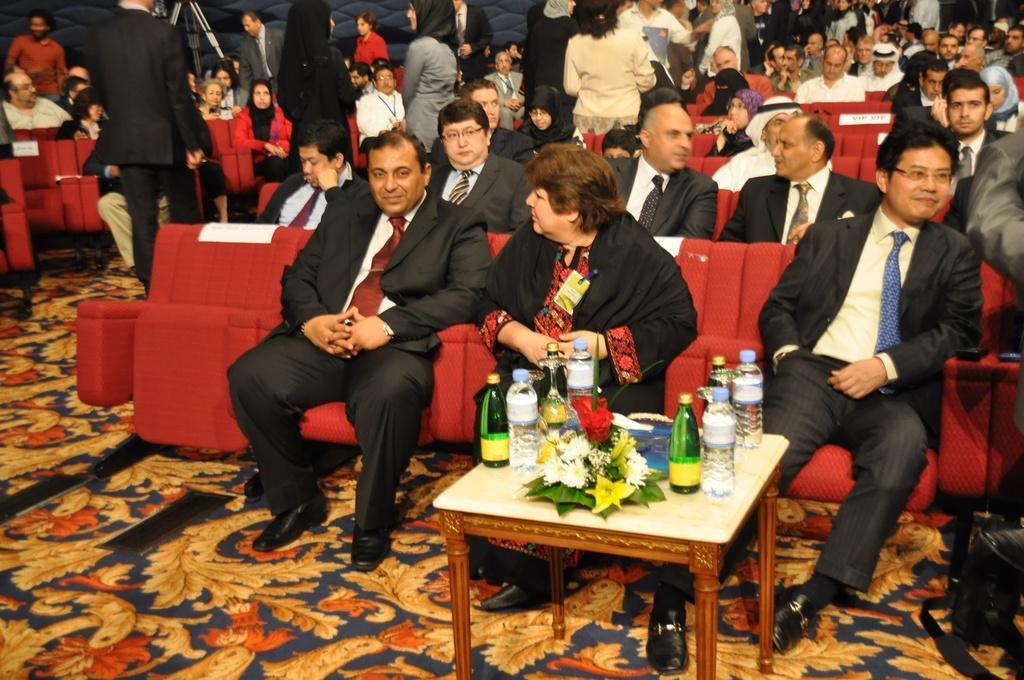How would you summarize this image in a sentence or two? In the image few people are sitting and standing. In the middle of the image there is a table, On the table there are some bottles and there is a flower bouquet. 